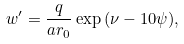<formula> <loc_0><loc_0><loc_500><loc_500>w ^ { \prime } = \frac { q } { a r _ { 0 } } \exp { ( \nu - 1 0 \psi ) } ,</formula> 